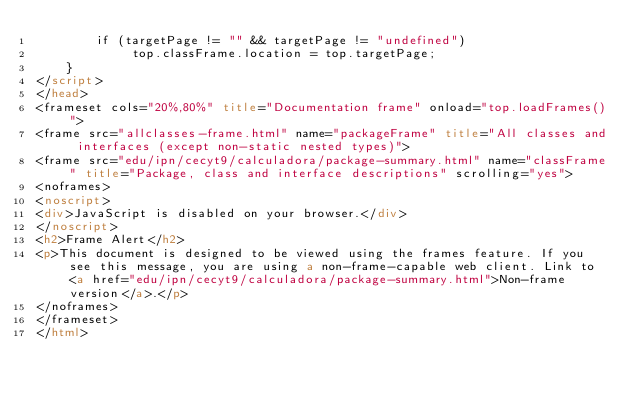Convert code to text. <code><loc_0><loc_0><loc_500><loc_500><_HTML_>        if (targetPage != "" && targetPage != "undefined")
             top.classFrame.location = top.targetPage;
    }
</script>
</head>
<frameset cols="20%,80%" title="Documentation frame" onload="top.loadFrames()">
<frame src="allclasses-frame.html" name="packageFrame" title="All classes and interfaces (except non-static nested types)">
<frame src="edu/ipn/cecyt9/calculadora/package-summary.html" name="classFrame" title="Package, class and interface descriptions" scrolling="yes">
<noframes>
<noscript>
<div>JavaScript is disabled on your browser.</div>
</noscript>
<h2>Frame Alert</h2>
<p>This document is designed to be viewed using the frames feature. If you see this message, you are using a non-frame-capable web client. Link to <a href="edu/ipn/cecyt9/calculadora/package-summary.html">Non-frame version</a>.</p>
</noframes>
</frameset>
</html>
</code> 